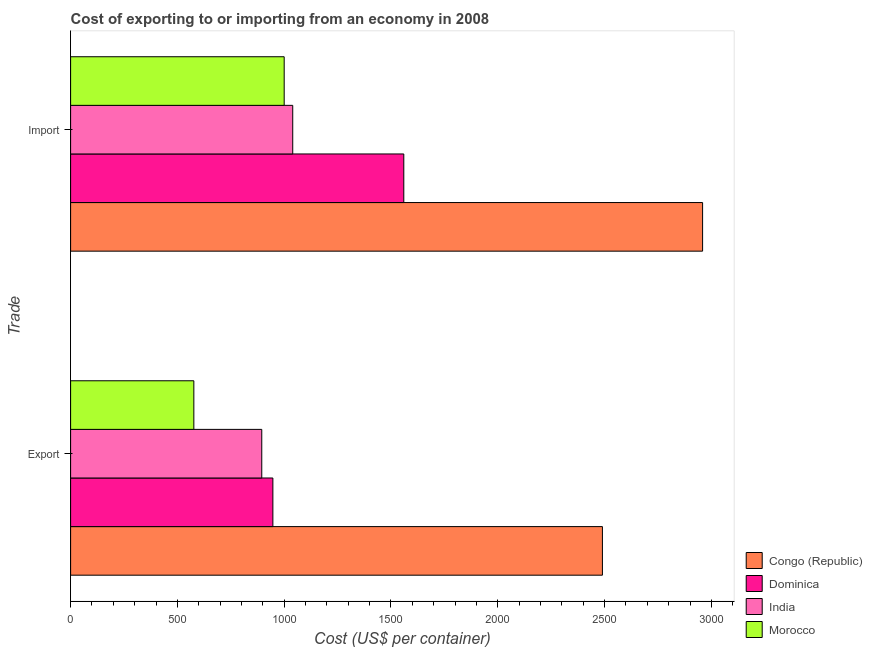Are the number of bars on each tick of the Y-axis equal?
Offer a terse response. Yes. How many bars are there on the 1st tick from the top?
Your answer should be very brief. 4. How many bars are there on the 2nd tick from the bottom?
Provide a short and direct response. 4. What is the label of the 1st group of bars from the top?
Provide a short and direct response. Import. What is the export cost in Morocco?
Provide a short and direct response. 577. Across all countries, what is the maximum export cost?
Offer a terse response. 2490. Across all countries, what is the minimum import cost?
Give a very brief answer. 1000. In which country was the import cost maximum?
Provide a short and direct response. Congo (Republic). In which country was the import cost minimum?
Keep it short and to the point. Morocco. What is the total import cost in the graph?
Provide a short and direct response. 6559. What is the difference between the export cost in Congo (Republic) and that in India?
Offer a very short reply. 1595. What is the difference between the export cost in Morocco and the import cost in Dominica?
Your response must be concise. -983. What is the average import cost per country?
Provide a succinct answer. 1639.75. What is the difference between the import cost and export cost in Morocco?
Your answer should be very brief. 423. In how many countries, is the import cost greater than 2200 US$?
Your answer should be compact. 1. What is the ratio of the import cost in Morocco to that in Dominica?
Keep it short and to the point. 0.64. Is the import cost in Morocco less than that in Dominica?
Provide a short and direct response. Yes. What does the 4th bar from the top in Import represents?
Provide a succinct answer. Congo (Republic). What does the 1st bar from the bottom in Import represents?
Offer a very short reply. Congo (Republic). Are all the bars in the graph horizontal?
Make the answer very short. Yes. What is the difference between two consecutive major ticks on the X-axis?
Your response must be concise. 500. Are the values on the major ticks of X-axis written in scientific E-notation?
Offer a terse response. No. Does the graph contain any zero values?
Make the answer very short. No. How many legend labels are there?
Your answer should be compact. 4. What is the title of the graph?
Your answer should be very brief. Cost of exporting to or importing from an economy in 2008. Does "Norway" appear as one of the legend labels in the graph?
Your response must be concise. No. What is the label or title of the X-axis?
Offer a terse response. Cost (US$ per container). What is the label or title of the Y-axis?
Your answer should be very brief. Trade. What is the Cost (US$ per container) of Congo (Republic) in Export?
Your answer should be very brief. 2490. What is the Cost (US$ per container) of Dominica in Export?
Make the answer very short. 947. What is the Cost (US$ per container) in India in Export?
Offer a very short reply. 895. What is the Cost (US$ per container) of Morocco in Export?
Ensure brevity in your answer.  577. What is the Cost (US$ per container) in Congo (Republic) in Import?
Your response must be concise. 2959. What is the Cost (US$ per container) in Dominica in Import?
Provide a short and direct response. 1560. What is the Cost (US$ per container) in India in Import?
Provide a short and direct response. 1040. What is the Cost (US$ per container) of Morocco in Import?
Provide a short and direct response. 1000. Across all Trade, what is the maximum Cost (US$ per container) of Congo (Republic)?
Offer a very short reply. 2959. Across all Trade, what is the maximum Cost (US$ per container) in Dominica?
Provide a short and direct response. 1560. Across all Trade, what is the maximum Cost (US$ per container) of India?
Provide a succinct answer. 1040. Across all Trade, what is the maximum Cost (US$ per container) in Morocco?
Provide a short and direct response. 1000. Across all Trade, what is the minimum Cost (US$ per container) of Congo (Republic)?
Ensure brevity in your answer.  2490. Across all Trade, what is the minimum Cost (US$ per container) in Dominica?
Give a very brief answer. 947. Across all Trade, what is the minimum Cost (US$ per container) of India?
Offer a terse response. 895. Across all Trade, what is the minimum Cost (US$ per container) of Morocco?
Ensure brevity in your answer.  577. What is the total Cost (US$ per container) of Congo (Republic) in the graph?
Your response must be concise. 5449. What is the total Cost (US$ per container) of Dominica in the graph?
Your response must be concise. 2507. What is the total Cost (US$ per container) in India in the graph?
Your answer should be very brief. 1935. What is the total Cost (US$ per container) in Morocco in the graph?
Your response must be concise. 1577. What is the difference between the Cost (US$ per container) in Congo (Republic) in Export and that in Import?
Provide a short and direct response. -469. What is the difference between the Cost (US$ per container) of Dominica in Export and that in Import?
Offer a very short reply. -613. What is the difference between the Cost (US$ per container) in India in Export and that in Import?
Ensure brevity in your answer.  -145. What is the difference between the Cost (US$ per container) of Morocco in Export and that in Import?
Provide a short and direct response. -423. What is the difference between the Cost (US$ per container) in Congo (Republic) in Export and the Cost (US$ per container) in Dominica in Import?
Give a very brief answer. 930. What is the difference between the Cost (US$ per container) in Congo (Republic) in Export and the Cost (US$ per container) in India in Import?
Provide a short and direct response. 1450. What is the difference between the Cost (US$ per container) of Congo (Republic) in Export and the Cost (US$ per container) of Morocco in Import?
Give a very brief answer. 1490. What is the difference between the Cost (US$ per container) of Dominica in Export and the Cost (US$ per container) of India in Import?
Keep it short and to the point. -93. What is the difference between the Cost (US$ per container) of Dominica in Export and the Cost (US$ per container) of Morocco in Import?
Offer a terse response. -53. What is the difference between the Cost (US$ per container) of India in Export and the Cost (US$ per container) of Morocco in Import?
Your answer should be very brief. -105. What is the average Cost (US$ per container) in Congo (Republic) per Trade?
Keep it short and to the point. 2724.5. What is the average Cost (US$ per container) of Dominica per Trade?
Your answer should be very brief. 1253.5. What is the average Cost (US$ per container) of India per Trade?
Your answer should be compact. 967.5. What is the average Cost (US$ per container) in Morocco per Trade?
Provide a short and direct response. 788.5. What is the difference between the Cost (US$ per container) in Congo (Republic) and Cost (US$ per container) in Dominica in Export?
Your response must be concise. 1543. What is the difference between the Cost (US$ per container) in Congo (Republic) and Cost (US$ per container) in India in Export?
Your answer should be very brief. 1595. What is the difference between the Cost (US$ per container) of Congo (Republic) and Cost (US$ per container) of Morocco in Export?
Your answer should be compact. 1913. What is the difference between the Cost (US$ per container) of Dominica and Cost (US$ per container) of India in Export?
Offer a very short reply. 52. What is the difference between the Cost (US$ per container) of Dominica and Cost (US$ per container) of Morocco in Export?
Offer a very short reply. 370. What is the difference between the Cost (US$ per container) in India and Cost (US$ per container) in Morocco in Export?
Offer a very short reply. 318. What is the difference between the Cost (US$ per container) of Congo (Republic) and Cost (US$ per container) of Dominica in Import?
Offer a terse response. 1399. What is the difference between the Cost (US$ per container) in Congo (Republic) and Cost (US$ per container) in India in Import?
Offer a terse response. 1919. What is the difference between the Cost (US$ per container) of Congo (Republic) and Cost (US$ per container) of Morocco in Import?
Keep it short and to the point. 1959. What is the difference between the Cost (US$ per container) of Dominica and Cost (US$ per container) of India in Import?
Your answer should be compact. 520. What is the difference between the Cost (US$ per container) in Dominica and Cost (US$ per container) in Morocco in Import?
Offer a very short reply. 560. What is the difference between the Cost (US$ per container) in India and Cost (US$ per container) in Morocco in Import?
Ensure brevity in your answer.  40. What is the ratio of the Cost (US$ per container) in Congo (Republic) in Export to that in Import?
Keep it short and to the point. 0.84. What is the ratio of the Cost (US$ per container) in Dominica in Export to that in Import?
Make the answer very short. 0.61. What is the ratio of the Cost (US$ per container) of India in Export to that in Import?
Offer a terse response. 0.86. What is the ratio of the Cost (US$ per container) in Morocco in Export to that in Import?
Offer a very short reply. 0.58. What is the difference between the highest and the second highest Cost (US$ per container) in Congo (Republic)?
Ensure brevity in your answer.  469. What is the difference between the highest and the second highest Cost (US$ per container) of Dominica?
Your answer should be very brief. 613. What is the difference between the highest and the second highest Cost (US$ per container) of India?
Offer a very short reply. 145. What is the difference between the highest and the second highest Cost (US$ per container) in Morocco?
Make the answer very short. 423. What is the difference between the highest and the lowest Cost (US$ per container) of Congo (Republic)?
Offer a terse response. 469. What is the difference between the highest and the lowest Cost (US$ per container) of Dominica?
Your response must be concise. 613. What is the difference between the highest and the lowest Cost (US$ per container) of India?
Your response must be concise. 145. What is the difference between the highest and the lowest Cost (US$ per container) in Morocco?
Give a very brief answer. 423. 